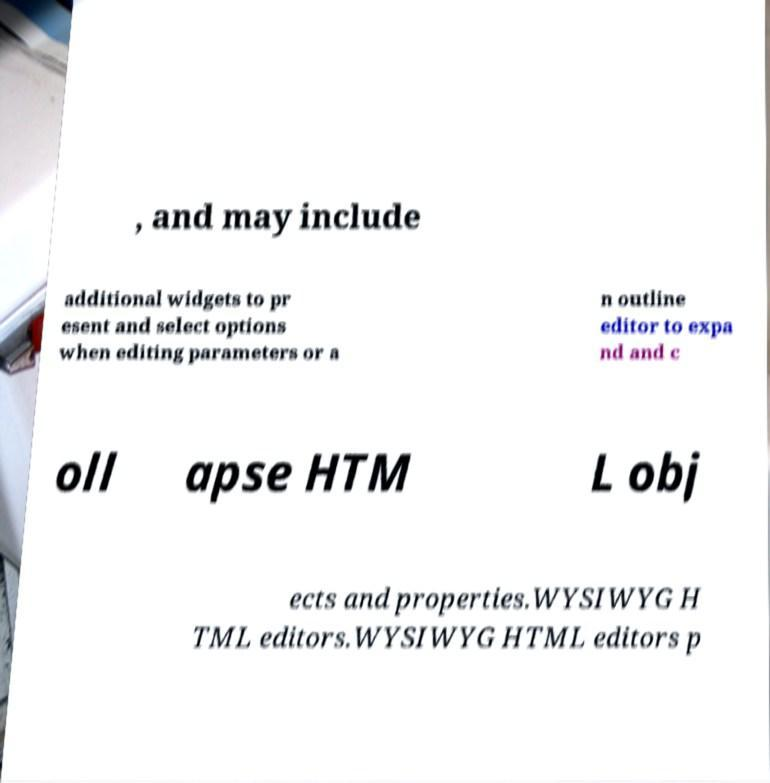Please read and relay the text visible in this image. What does it say? , and may include additional widgets to pr esent and select options when editing parameters or a n outline editor to expa nd and c oll apse HTM L obj ects and properties.WYSIWYG H TML editors.WYSIWYG HTML editors p 